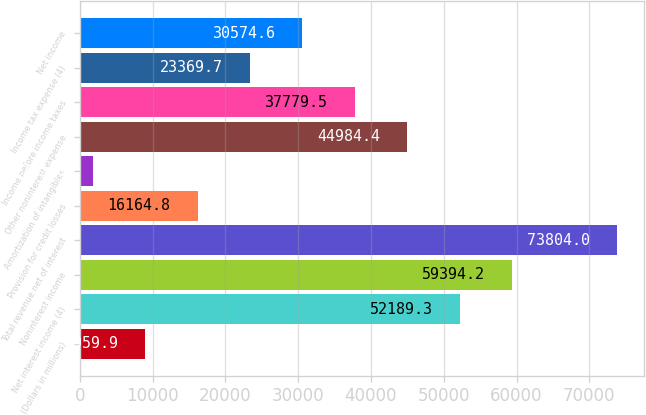<chart> <loc_0><loc_0><loc_500><loc_500><bar_chart><fcel>(Dollars in millions)<fcel>Net interest income (4)<fcel>Noninterest income<fcel>Total revenue net of interest<fcel>Provision for credit losses<fcel>Amortization of intangibles<fcel>Other noninterest expense<fcel>Income before income taxes<fcel>Income tax expense (4)<fcel>Net income<nl><fcel>8959.9<fcel>52189.3<fcel>59394.2<fcel>73804<fcel>16164.8<fcel>1755<fcel>44984.4<fcel>37779.5<fcel>23369.7<fcel>30574.6<nl></chart> 